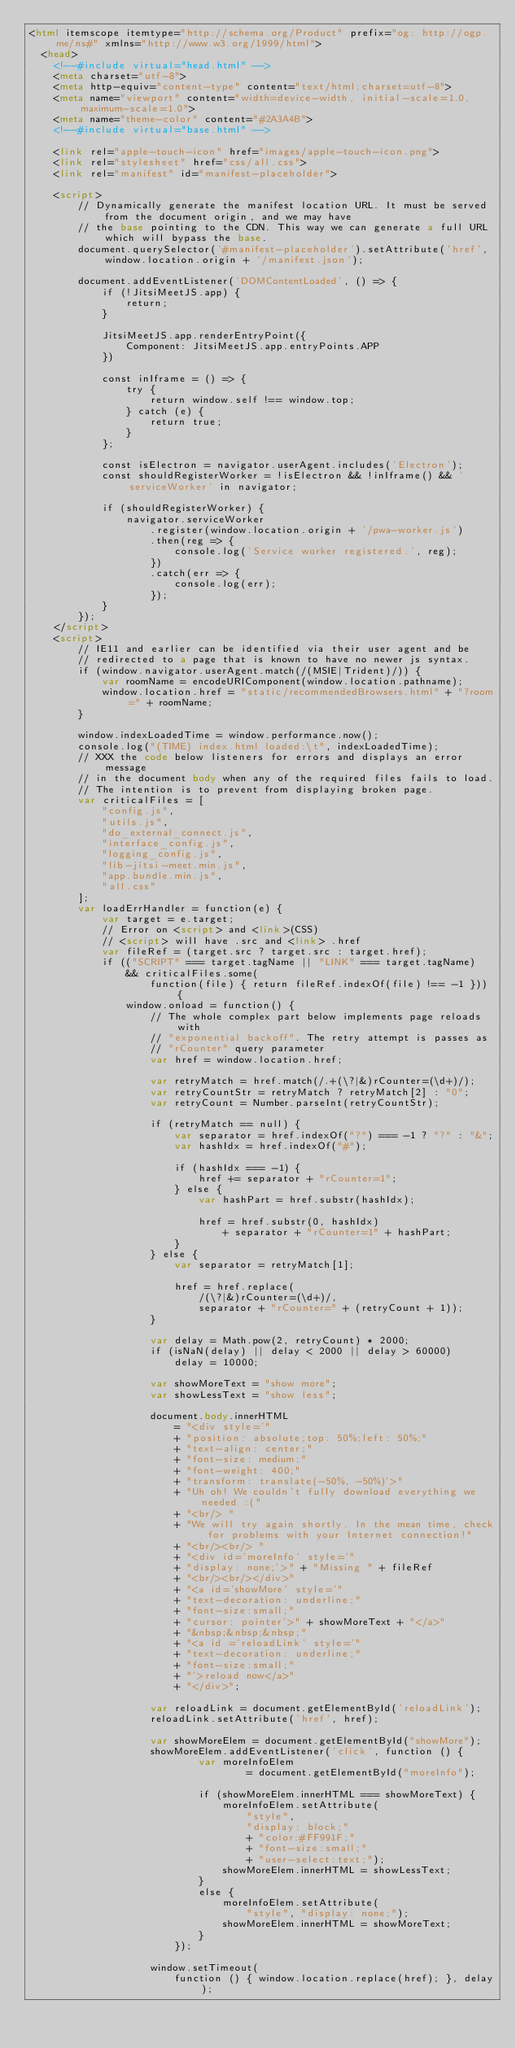Convert code to text. <code><loc_0><loc_0><loc_500><loc_500><_HTML_><html itemscope itemtype="http://schema.org/Product" prefix="og: http://ogp.me/ns#" xmlns="http://www.w3.org/1999/html">
  <head>
    <!--#include virtual="head.html" -->
    <meta charset="utf-8">
    <meta http-equiv="content-type" content="text/html;charset=utf-8">
    <meta name="viewport" content="width=device-width, initial-scale=1.0, maximum-scale=1.0">
    <meta name="theme-color" content="#2A3A4B">
    <!--#include virtual="base.html" -->

    <link rel="apple-touch-icon" href="images/apple-touch-icon.png">
    <link rel="stylesheet" href="css/all.css">
    <link rel="manifest" id="manifest-placeholder">

    <script>
        // Dynamically generate the manifest location URL. It must be served from the document origin, and we may have
        // the base pointing to the CDN. This way we can generate a full URL which will bypass the base.
        document.querySelector('#manifest-placeholder').setAttribute('href', window.location.origin + '/manifest.json');

        document.addEventListener('DOMContentLoaded', () => {
            if (!JitsiMeetJS.app) {
                return;
            }

            JitsiMeetJS.app.renderEntryPoint({
                Component: JitsiMeetJS.app.entryPoints.APP
            })

            const inIframe = () => {
                try {
                    return window.self !== window.top;
                } catch (e) {
                    return true;
                }
            };

            const isElectron = navigator.userAgent.includes('Electron');
            const shouldRegisterWorker = !isElectron && !inIframe() && 'serviceWorker' in navigator;

            if (shouldRegisterWorker) {
                navigator.serviceWorker
                    .register(window.location.origin + '/pwa-worker.js')
                    .then(reg => {
                        console.log('Service worker registered.', reg);
                    })
                    .catch(err => {
                        console.log(err);
                    });
            }
        });
    </script>
    <script>
        // IE11 and earlier can be identified via their user agent and be
        // redirected to a page that is known to have no newer js syntax.
        if (window.navigator.userAgent.match(/(MSIE|Trident)/)) {
            var roomName = encodeURIComponent(window.location.pathname);
            window.location.href = "static/recommendedBrowsers.html" + "?room=" + roomName;
        }

        window.indexLoadedTime = window.performance.now();
        console.log("(TIME) index.html loaded:\t", indexLoadedTime);
        // XXX the code below listeners for errors and displays an error message
        // in the document body when any of the required files fails to load.
        // The intention is to prevent from displaying broken page.
        var criticalFiles = [
            "config.js",
            "utils.js",
            "do_external_connect.js",
            "interface_config.js",
            "logging_config.js",
            "lib-jitsi-meet.min.js",
            "app.bundle.min.js",
            "all.css"
        ];
        var loadErrHandler = function(e) {
            var target = e.target;
            // Error on <script> and <link>(CSS)
            // <script> will have .src and <link> .href
            var fileRef = (target.src ? target.src : target.href);
            if (("SCRIPT" === target.tagName || "LINK" === target.tagName)
                && criticalFiles.some(
                    function(file) { return fileRef.indexOf(file) !== -1 })) {
                window.onload = function() {
                    // The whole complex part below implements page reloads with
                    // "exponential backoff". The retry attempt is passes as
                    // "rCounter" query parameter
                    var href = window.location.href;

                    var retryMatch = href.match(/.+(\?|&)rCounter=(\d+)/);
                    var retryCountStr = retryMatch ? retryMatch[2] : "0";
                    var retryCount = Number.parseInt(retryCountStr);

                    if (retryMatch == null) {
                        var separator = href.indexOf("?") === -1 ? "?" : "&";
                        var hashIdx = href.indexOf("#");

                        if (hashIdx === -1) {
                            href += separator + "rCounter=1";
                        } else {
                            var hashPart = href.substr(hashIdx);

                            href = href.substr(0, hashIdx)
                                + separator + "rCounter=1" + hashPart;
                        }
                    } else {
                        var separator = retryMatch[1];

                        href = href.replace(
                            /(\?|&)rCounter=(\d+)/,
                            separator + "rCounter=" + (retryCount + 1));
                    }

                    var delay = Math.pow(2, retryCount) * 2000;
                    if (isNaN(delay) || delay < 2000 || delay > 60000)
                        delay = 10000;

                    var showMoreText = "show more";
                    var showLessText = "show less";

                    document.body.innerHTML
                        = "<div style='"
                        + "position: absolute;top: 50%;left: 50%;"
                        + "text-align: center;"
                        + "font-size: medium;"
                        + "font-weight: 400;"
                        + "transform: translate(-50%, -50%)'>"
                        + "Uh oh! We couldn't fully download everything we needed :("
                        + "<br/> "
                        + "We will try again shortly. In the mean time, check for problems with your Internet connection!"
                        + "<br/><br/> "
                        + "<div id='moreInfo' style='"
                        + "display: none;'>" + "Missing " + fileRef
                        + "<br/><br/></div>"
                        + "<a id='showMore' style='"
                        + "text-decoration: underline;"
                        + "font-size:small;"
                        + "cursor: pointer'>" + showMoreText + "</a>"
                        + "&nbsp;&nbsp;&nbsp;"
                        + "<a id ='reloadLink' style='"
                        + "text-decoration: underline;"
                        + "font-size:small;"
                        + "'>reload now</a>"
                        + "</div>";

                    var reloadLink = document.getElementById('reloadLink');
                    reloadLink.setAttribute('href', href);

                    var showMoreElem = document.getElementById("showMore");
                    showMoreElem.addEventListener('click', function () {
                            var moreInfoElem
                                    = document.getElementById("moreInfo");

                            if (showMoreElem.innerHTML === showMoreText) {
                                moreInfoElem.setAttribute(
                                    "style",
                                    "display: block;"
                                    + "color:#FF991F;"
                                    + "font-size:small;"
                                    + "user-select:text;");
                                showMoreElem.innerHTML = showLessText;
                            }
                            else {
                                moreInfoElem.setAttribute(
                                    "style", "display: none;");
                                showMoreElem.innerHTML = showMoreText;
                            }
                        });

                    window.setTimeout(
                        function () { window.location.replace(href); }, delay);
</code> 